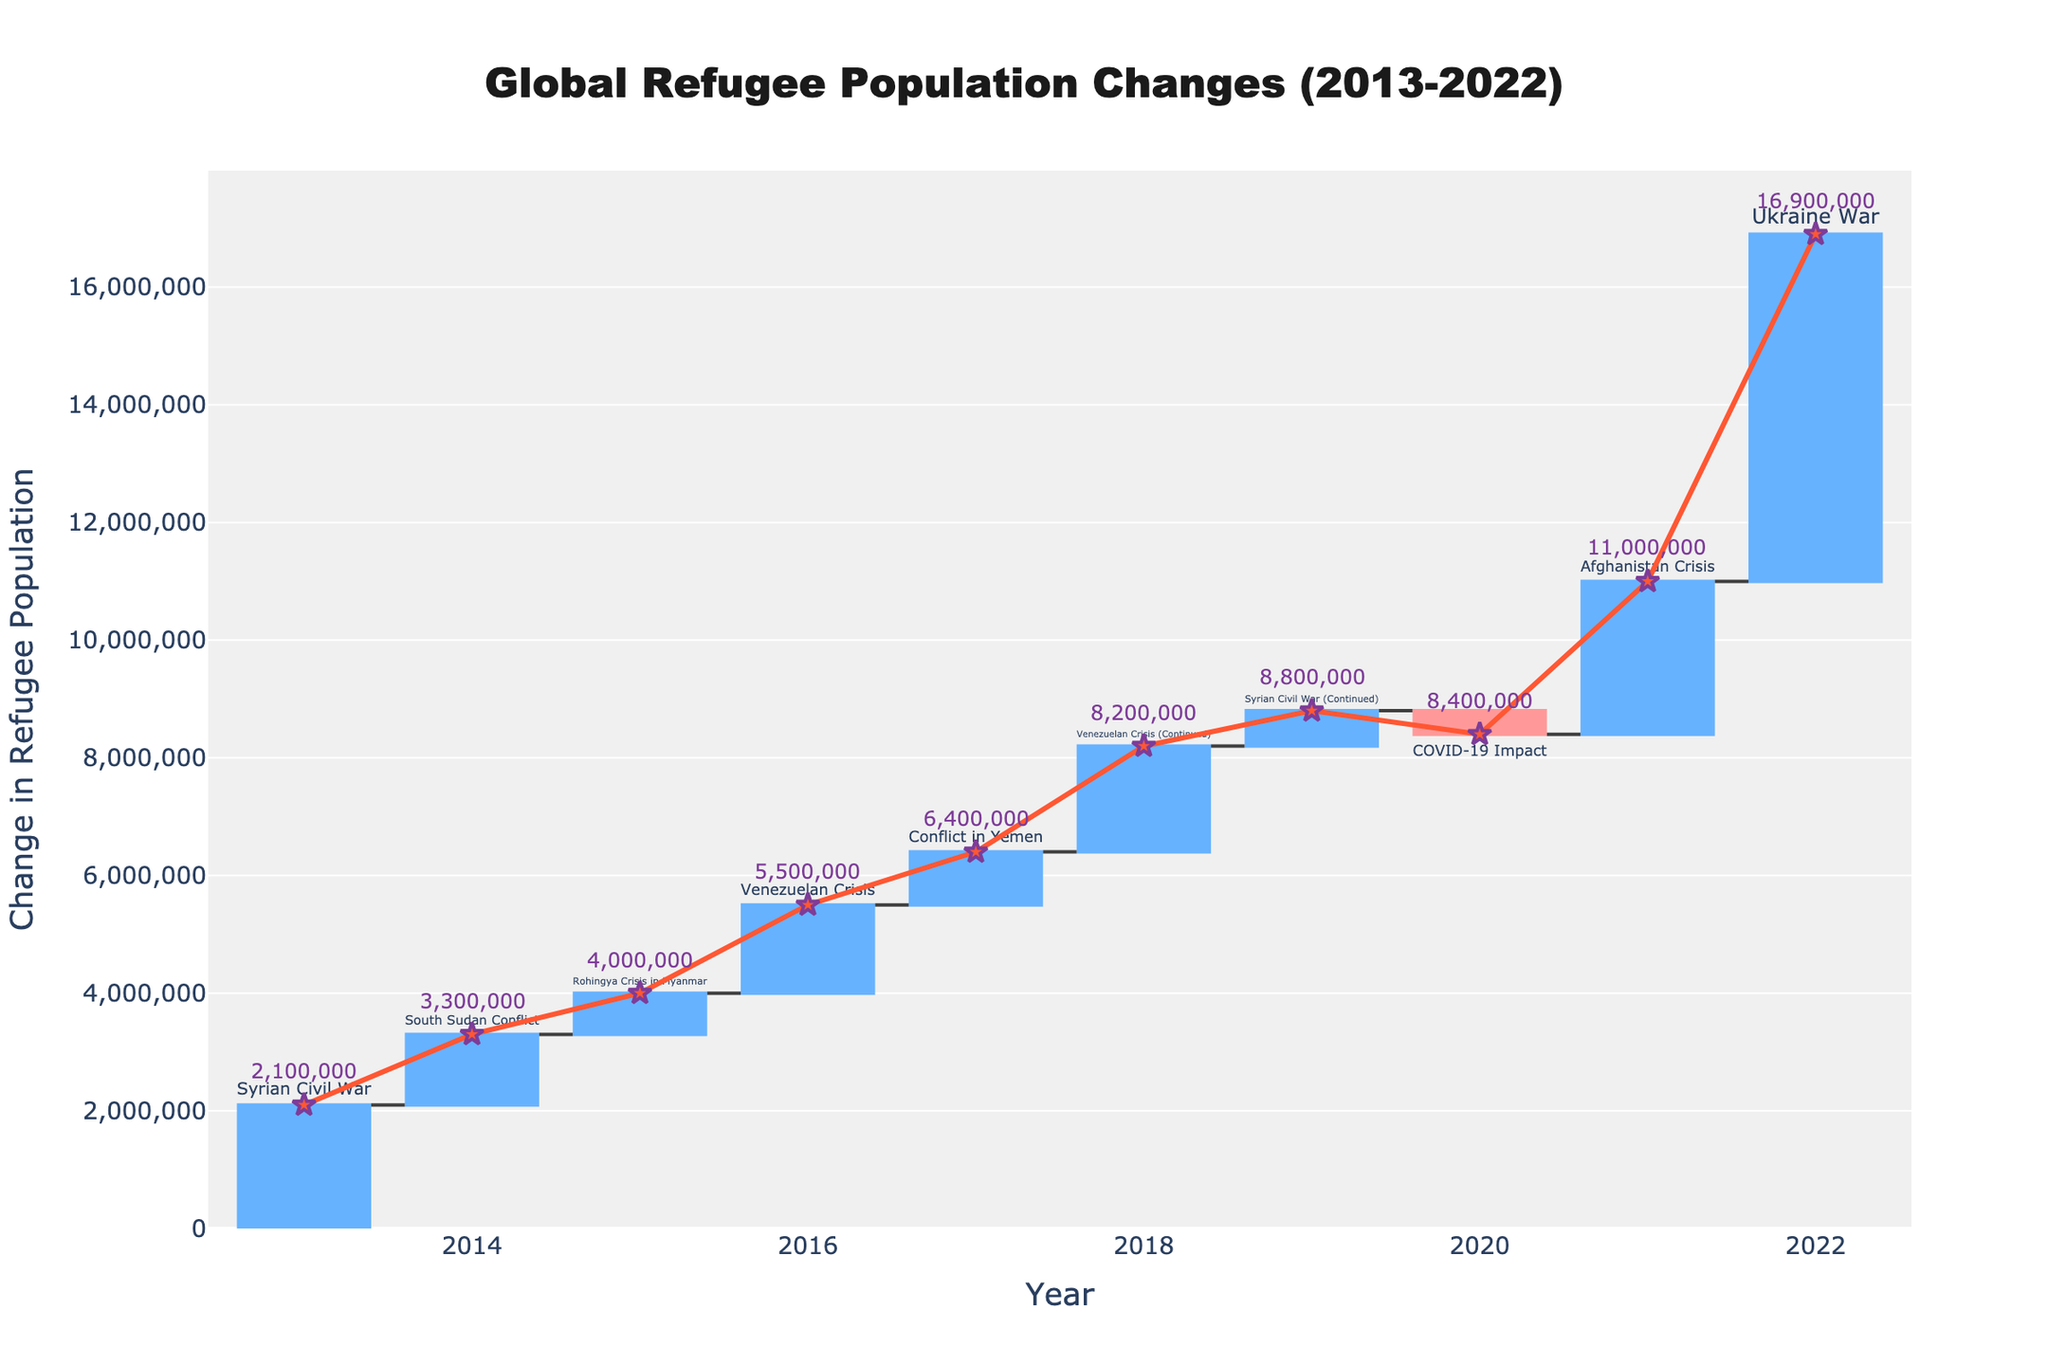What is the title of the figure? The title is usually displayed prominently at the top of the chart. By observing the figure, we see "Global Refugee Population Changes (2013-2022)" clearly stated as the title.
Answer: Global Refugee Population Changes (2013-2022) How many major refugee population changes are shown? Each bar in the waterfall chart represents a significant event impacting the refugee population. Counting these bars, we see that there are 10 major events displayed.
Answer: 10 What event caused the highest increase in the refugee population? By examining the heights of the bars in the waterfall chart, the bar corresponding to the Ukraine War in 2022 is the tallest, indicating the highest increase.
Answer: Ukraine War What year saw a decrease in the refugee population? In a waterfall chart, decreases are often marked in a different color. By locating the bar colored differently, we identify that 2020 saw a decrease due to the COVID-19 Impact.
Answer: 2020 How many events are associated with the Venezuelan Crisis? By checking the event names associated with each bar, we see that the Venezuelan Crisis appears twice (2016 and 2018).
Answer: 2 What is the total cumulative change in refugee population by the end of 2022? The cumulative change line indicates the total sum of all previous changes by the current year. At the end of the chart (2022), the annotated number shows the total cumulative change.
Answer: 14,200,000 Which event had the smallest increase in the refugee population? Looking at the heights of the increasing bars, the shortest one corresponds to the Rohingya Crisis in 2015.
Answer: Rohingya Crisis in Myanmar Compare the refugee population changes between the Syrian Civil War and the Afghanistan Crisis. Which one had a greater impact? The Syrian Civil War and Afghanistan Crisis bars should be compared, noting their heights. The Afghanistan Crisis in 2021 has a taller bar, indicating a greater impact.
Answer: Afghanistan Crisis What is the cumulative refugee population change by 2018? To find this, look at the cumulative change line and its annotation at the year 2018, which indicates the cumulative total at that point.
Answer: 7,200,000 How much did the refugee population change due to the COVID-19 Impact? The COVID-19 Impact in 2020 is represented by a decrease. Checking the negative value associated with this bar gives us the change.
Answer: -400,000 